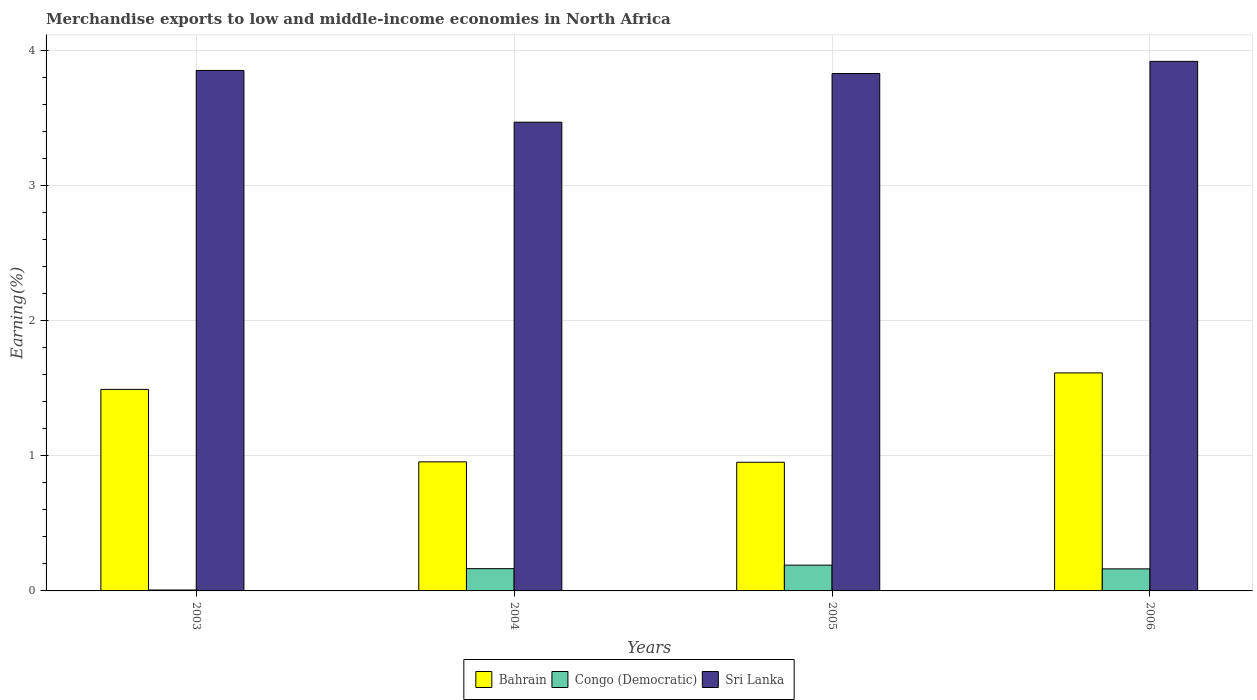How many different coloured bars are there?
Ensure brevity in your answer.  3. How many groups of bars are there?
Offer a terse response. 4. Are the number of bars per tick equal to the number of legend labels?
Give a very brief answer. Yes. What is the percentage of amount earned from merchandise exports in Bahrain in 2006?
Your response must be concise. 1.61. Across all years, what is the maximum percentage of amount earned from merchandise exports in Sri Lanka?
Your answer should be compact. 3.92. Across all years, what is the minimum percentage of amount earned from merchandise exports in Congo (Democratic)?
Offer a very short reply. 0.01. In which year was the percentage of amount earned from merchandise exports in Bahrain maximum?
Keep it short and to the point. 2006. In which year was the percentage of amount earned from merchandise exports in Congo (Democratic) minimum?
Your response must be concise. 2003. What is the total percentage of amount earned from merchandise exports in Congo (Democratic) in the graph?
Your answer should be very brief. 0.53. What is the difference between the percentage of amount earned from merchandise exports in Sri Lanka in 2004 and that in 2005?
Offer a terse response. -0.36. What is the difference between the percentage of amount earned from merchandise exports in Bahrain in 2003 and the percentage of amount earned from merchandise exports in Congo (Democratic) in 2006?
Your response must be concise. 1.33. What is the average percentage of amount earned from merchandise exports in Congo (Democratic) per year?
Your response must be concise. 0.13. In the year 2003, what is the difference between the percentage of amount earned from merchandise exports in Congo (Democratic) and percentage of amount earned from merchandise exports in Sri Lanka?
Offer a very short reply. -3.84. In how many years, is the percentage of amount earned from merchandise exports in Sri Lanka greater than 2 %?
Offer a very short reply. 4. What is the ratio of the percentage of amount earned from merchandise exports in Congo (Democratic) in 2005 to that in 2006?
Offer a terse response. 1.17. Is the difference between the percentage of amount earned from merchandise exports in Congo (Democratic) in 2004 and 2006 greater than the difference between the percentage of amount earned from merchandise exports in Sri Lanka in 2004 and 2006?
Provide a succinct answer. Yes. What is the difference between the highest and the second highest percentage of amount earned from merchandise exports in Sri Lanka?
Keep it short and to the point. 0.07. What is the difference between the highest and the lowest percentage of amount earned from merchandise exports in Sri Lanka?
Ensure brevity in your answer.  0.45. In how many years, is the percentage of amount earned from merchandise exports in Sri Lanka greater than the average percentage of amount earned from merchandise exports in Sri Lanka taken over all years?
Ensure brevity in your answer.  3. What does the 1st bar from the left in 2006 represents?
Provide a short and direct response. Bahrain. What does the 2nd bar from the right in 2003 represents?
Your response must be concise. Congo (Democratic). Does the graph contain any zero values?
Make the answer very short. No. Where does the legend appear in the graph?
Make the answer very short. Bottom center. How many legend labels are there?
Provide a succinct answer. 3. What is the title of the graph?
Offer a terse response. Merchandise exports to low and middle-income economies in North Africa. What is the label or title of the X-axis?
Keep it short and to the point. Years. What is the label or title of the Y-axis?
Make the answer very short. Earning(%). What is the Earning(%) of Bahrain in 2003?
Offer a terse response. 1.49. What is the Earning(%) in Congo (Democratic) in 2003?
Keep it short and to the point. 0.01. What is the Earning(%) of Sri Lanka in 2003?
Your answer should be very brief. 3.85. What is the Earning(%) in Bahrain in 2004?
Provide a succinct answer. 0.95. What is the Earning(%) in Congo (Democratic) in 2004?
Your answer should be compact. 0.16. What is the Earning(%) of Sri Lanka in 2004?
Your answer should be very brief. 3.47. What is the Earning(%) in Bahrain in 2005?
Your response must be concise. 0.95. What is the Earning(%) of Congo (Democratic) in 2005?
Ensure brevity in your answer.  0.19. What is the Earning(%) in Sri Lanka in 2005?
Your response must be concise. 3.83. What is the Earning(%) in Bahrain in 2006?
Your answer should be very brief. 1.61. What is the Earning(%) of Congo (Democratic) in 2006?
Your response must be concise. 0.16. What is the Earning(%) in Sri Lanka in 2006?
Provide a short and direct response. 3.92. Across all years, what is the maximum Earning(%) in Bahrain?
Your response must be concise. 1.61. Across all years, what is the maximum Earning(%) in Congo (Democratic)?
Provide a succinct answer. 0.19. Across all years, what is the maximum Earning(%) in Sri Lanka?
Your answer should be very brief. 3.92. Across all years, what is the minimum Earning(%) in Bahrain?
Your answer should be compact. 0.95. Across all years, what is the minimum Earning(%) of Congo (Democratic)?
Your answer should be very brief. 0.01. Across all years, what is the minimum Earning(%) of Sri Lanka?
Offer a very short reply. 3.47. What is the total Earning(%) of Bahrain in the graph?
Your response must be concise. 5.01. What is the total Earning(%) in Congo (Democratic) in the graph?
Offer a very short reply. 0.53. What is the total Earning(%) of Sri Lanka in the graph?
Provide a succinct answer. 15.06. What is the difference between the Earning(%) in Bahrain in 2003 and that in 2004?
Provide a short and direct response. 0.54. What is the difference between the Earning(%) of Congo (Democratic) in 2003 and that in 2004?
Offer a terse response. -0.16. What is the difference between the Earning(%) of Sri Lanka in 2003 and that in 2004?
Provide a succinct answer. 0.38. What is the difference between the Earning(%) of Bahrain in 2003 and that in 2005?
Your answer should be compact. 0.54. What is the difference between the Earning(%) in Congo (Democratic) in 2003 and that in 2005?
Make the answer very short. -0.18. What is the difference between the Earning(%) in Sri Lanka in 2003 and that in 2005?
Provide a succinct answer. 0.02. What is the difference between the Earning(%) of Bahrain in 2003 and that in 2006?
Ensure brevity in your answer.  -0.12. What is the difference between the Earning(%) in Congo (Democratic) in 2003 and that in 2006?
Provide a short and direct response. -0.16. What is the difference between the Earning(%) of Sri Lanka in 2003 and that in 2006?
Give a very brief answer. -0.07. What is the difference between the Earning(%) of Bahrain in 2004 and that in 2005?
Your answer should be compact. 0. What is the difference between the Earning(%) of Congo (Democratic) in 2004 and that in 2005?
Provide a short and direct response. -0.03. What is the difference between the Earning(%) of Sri Lanka in 2004 and that in 2005?
Make the answer very short. -0.36. What is the difference between the Earning(%) in Bahrain in 2004 and that in 2006?
Provide a short and direct response. -0.66. What is the difference between the Earning(%) of Congo (Democratic) in 2004 and that in 2006?
Give a very brief answer. 0. What is the difference between the Earning(%) of Sri Lanka in 2004 and that in 2006?
Offer a terse response. -0.45. What is the difference between the Earning(%) of Bahrain in 2005 and that in 2006?
Make the answer very short. -0.66. What is the difference between the Earning(%) in Congo (Democratic) in 2005 and that in 2006?
Your answer should be compact. 0.03. What is the difference between the Earning(%) in Sri Lanka in 2005 and that in 2006?
Give a very brief answer. -0.09. What is the difference between the Earning(%) of Bahrain in 2003 and the Earning(%) of Congo (Democratic) in 2004?
Provide a succinct answer. 1.33. What is the difference between the Earning(%) of Bahrain in 2003 and the Earning(%) of Sri Lanka in 2004?
Offer a very short reply. -1.98. What is the difference between the Earning(%) of Congo (Democratic) in 2003 and the Earning(%) of Sri Lanka in 2004?
Offer a very short reply. -3.46. What is the difference between the Earning(%) of Bahrain in 2003 and the Earning(%) of Congo (Democratic) in 2005?
Provide a succinct answer. 1.3. What is the difference between the Earning(%) of Bahrain in 2003 and the Earning(%) of Sri Lanka in 2005?
Provide a succinct answer. -2.34. What is the difference between the Earning(%) of Congo (Democratic) in 2003 and the Earning(%) of Sri Lanka in 2005?
Keep it short and to the point. -3.82. What is the difference between the Earning(%) of Bahrain in 2003 and the Earning(%) of Congo (Democratic) in 2006?
Provide a short and direct response. 1.33. What is the difference between the Earning(%) of Bahrain in 2003 and the Earning(%) of Sri Lanka in 2006?
Offer a very short reply. -2.43. What is the difference between the Earning(%) in Congo (Democratic) in 2003 and the Earning(%) in Sri Lanka in 2006?
Your answer should be very brief. -3.91. What is the difference between the Earning(%) of Bahrain in 2004 and the Earning(%) of Congo (Democratic) in 2005?
Make the answer very short. 0.76. What is the difference between the Earning(%) in Bahrain in 2004 and the Earning(%) in Sri Lanka in 2005?
Your answer should be very brief. -2.87. What is the difference between the Earning(%) of Congo (Democratic) in 2004 and the Earning(%) of Sri Lanka in 2005?
Provide a succinct answer. -3.66. What is the difference between the Earning(%) in Bahrain in 2004 and the Earning(%) in Congo (Democratic) in 2006?
Provide a short and direct response. 0.79. What is the difference between the Earning(%) of Bahrain in 2004 and the Earning(%) of Sri Lanka in 2006?
Provide a succinct answer. -2.96. What is the difference between the Earning(%) of Congo (Democratic) in 2004 and the Earning(%) of Sri Lanka in 2006?
Offer a very short reply. -3.75. What is the difference between the Earning(%) of Bahrain in 2005 and the Earning(%) of Congo (Democratic) in 2006?
Offer a very short reply. 0.79. What is the difference between the Earning(%) in Bahrain in 2005 and the Earning(%) in Sri Lanka in 2006?
Offer a terse response. -2.97. What is the difference between the Earning(%) of Congo (Democratic) in 2005 and the Earning(%) of Sri Lanka in 2006?
Offer a very short reply. -3.73. What is the average Earning(%) in Bahrain per year?
Provide a short and direct response. 1.25. What is the average Earning(%) of Congo (Democratic) per year?
Provide a short and direct response. 0.13. What is the average Earning(%) in Sri Lanka per year?
Give a very brief answer. 3.77. In the year 2003, what is the difference between the Earning(%) of Bahrain and Earning(%) of Congo (Democratic)?
Your answer should be compact. 1.48. In the year 2003, what is the difference between the Earning(%) in Bahrain and Earning(%) in Sri Lanka?
Provide a succinct answer. -2.36. In the year 2003, what is the difference between the Earning(%) in Congo (Democratic) and Earning(%) in Sri Lanka?
Make the answer very short. -3.84. In the year 2004, what is the difference between the Earning(%) in Bahrain and Earning(%) in Congo (Democratic)?
Keep it short and to the point. 0.79. In the year 2004, what is the difference between the Earning(%) of Bahrain and Earning(%) of Sri Lanka?
Give a very brief answer. -2.51. In the year 2004, what is the difference between the Earning(%) in Congo (Democratic) and Earning(%) in Sri Lanka?
Make the answer very short. -3.3. In the year 2005, what is the difference between the Earning(%) of Bahrain and Earning(%) of Congo (Democratic)?
Your response must be concise. 0.76. In the year 2005, what is the difference between the Earning(%) in Bahrain and Earning(%) in Sri Lanka?
Provide a succinct answer. -2.88. In the year 2005, what is the difference between the Earning(%) in Congo (Democratic) and Earning(%) in Sri Lanka?
Keep it short and to the point. -3.64. In the year 2006, what is the difference between the Earning(%) of Bahrain and Earning(%) of Congo (Democratic)?
Provide a succinct answer. 1.45. In the year 2006, what is the difference between the Earning(%) of Bahrain and Earning(%) of Sri Lanka?
Your response must be concise. -2.3. In the year 2006, what is the difference between the Earning(%) of Congo (Democratic) and Earning(%) of Sri Lanka?
Your response must be concise. -3.75. What is the ratio of the Earning(%) of Bahrain in 2003 to that in 2004?
Your response must be concise. 1.56. What is the ratio of the Earning(%) of Congo (Democratic) in 2003 to that in 2004?
Ensure brevity in your answer.  0.04. What is the ratio of the Earning(%) of Sri Lanka in 2003 to that in 2004?
Offer a terse response. 1.11. What is the ratio of the Earning(%) of Bahrain in 2003 to that in 2005?
Offer a very short reply. 1.57. What is the ratio of the Earning(%) of Congo (Democratic) in 2003 to that in 2005?
Offer a very short reply. 0.04. What is the ratio of the Earning(%) in Sri Lanka in 2003 to that in 2005?
Offer a terse response. 1.01. What is the ratio of the Earning(%) of Bahrain in 2003 to that in 2006?
Offer a very short reply. 0.92. What is the ratio of the Earning(%) in Congo (Democratic) in 2003 to that in 2006?
Offer a terse response. 0.04. What is the ratio of the Earning(%) in Sri Lanka in 2003 to that in 2006?
Keep it short and to the point. 0.98. What is the ratio of the Earning(%) of Congo (Democratic) in 2004 to that in 2005?
Your response must be concise. 0.86. What is the ratio of the Earning(%) in Sri Lanka in 2004 to that in 2005?
Make the answer very short. 0.91. What is the ratio of the Earning(%) in Bahrain in 2004 to that in 2006?
Ensure brevity in your answer.  0.59. What is the ratio of the Earning(%) in Congo (Democratic) in 2004 to that in 2006?
Your answer should be very brief. 1.01. What is the ratio of the Earning(%) of Sri Lanka in 2004 to that in 2006?
Your response must be concise. 0.89. What is the ratio of the Earning(%) in Bahrain in 2005 to that in 2006?
Your response must be concise. 0.59. What is the ratio of the Earning(%) of Congo (Democratic) in 2005 to that in 2006?
Your answer should be very brief. 1.17. What is the ratio of the Earning(%) in Sri Lanka in 2005 to that in 2006?
Make the answer very short. 0.98. What is the difference between the highest and the second highest Earning(%) of Bahrain?
Your answer should be very brief. 0.12. What is the difference between the highest and the second highest Earning(%) of Congo (Democratic)?
Your answer should be compact. 0.03. What is the difference between the highest and the second highest Earning(%) of Sri Lanka?
Your answer should be very brief. 0.07. What is the difference between the highest and the lowest Earning(%) in Bahrain?
Make the answer very short. 0.66. What is the difference between the highest and the lowest Earning(%) in Congo (Democratic)?
Give a very brief answer. 0.18. What is the difference between the highest and the lowest Earning(%) of Sri Lanka?
Your answer should be compact. 0.45. 